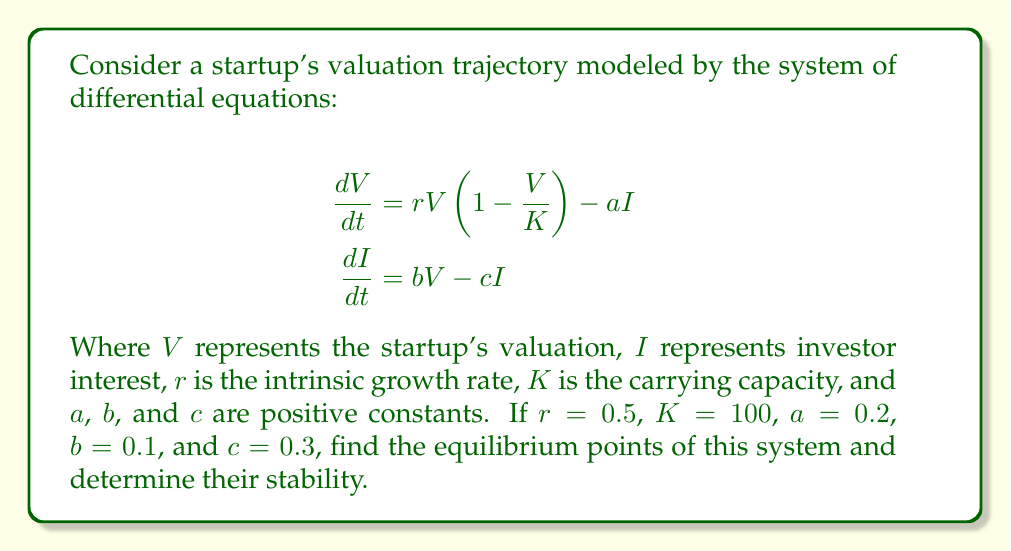What is the answer to this math problem? 1. To find the equilibrium points, we set both equations to zero:

   $$0 = rV(1-\frac{V}{K}) - aI$$
   $$0 = bV - cI$$

2. From the second equation:
   $$I = \frac{bV}{c}$$

3. Substitute this into the first equation:
   $$0 = rV(1-\frac{V}{K}) - a(\frac{bV}{c})$$

4. Simplify:
   $$0 = rV - \frac{rV^2}{K} - \frac{abV}{c}$$
   $$0 = V(r - \frac{rV}{K} - \frac{ab}{c})$$

5. Factor out V:
   $$V(r - \frac{rV}{K} - \frac{ab}{c}) = 0$$

6. This equation is satisfied when $V=0$ or when the term in parentheses is zero. Solve for V in the second case:
   $$r - \frac{rV}{K} - \frac{ab}{c} = 0$$
   $$r - \frac{ab}{c} = \frac{rV}{K}$$
   $$V = K(1 - \frac{ab}{rc})$$

7. Substitute the given values:
   $$V = 100(1 - \frac{0.2 \cdot 0.1}{0.5 \cdot 0.3}) = 100(1 - \frac{1}{7.5}) = 86.67$$

8. For this non-zero equilibrium point, calculate I:
   $$I = \frac{bV}{c} = \frac{0.1 \cdot 86.67}{0.3} = 28.89$$

9. To determine stability, we need to calculate the Jacobian matrix at each equilibrium point:

   $$J = \begin{bmatrix}
   r(1-\frac{2V}{K}) - a & -a \\
   b & -c
   \end{bmatrix}$$

10. For the equilibrium point (0,0):
    $$J_{(0,0)} = \begin{bmatrix}
    0.5 & -0.2 \\
    0.1 & -0.3
    \end{bmatrix}$$

    The eigenvalues are 0.5 and -0.3. Since one eigenvalue is positive, this point is unstable.

11. For the equilibrium point (86.67, 28.89):
    $$J_{(86.67,28.89)} = \begin{bmatrix}
    -0.5 & -0.2 \\
    0.1 & -0.3
    \end{bmatrix}$$

    The eigenvalues are approximately -0.56 and -0.24. Since both eigenvalues are negative, this point is stable.
Answer: Equilibrium points: (0,0) unstable; (86.67, 28.89) stable. 